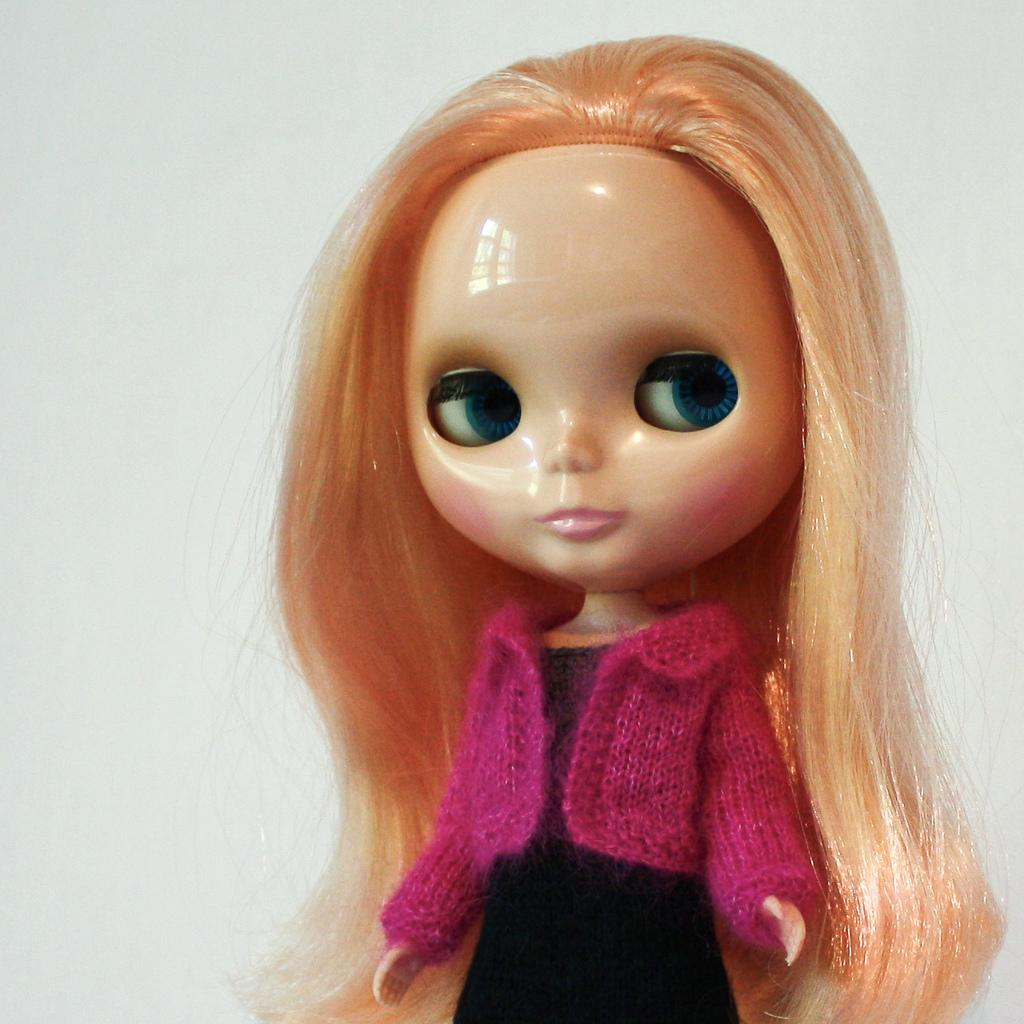What is the main subject in the image? There is a doll in the image. Can you describe the background of the image? There is a wall visible on the backside of the image. What type of knot is the doll trying to untie in the image? There is no knot present in the image, and the doll is not shown performing any actions. 